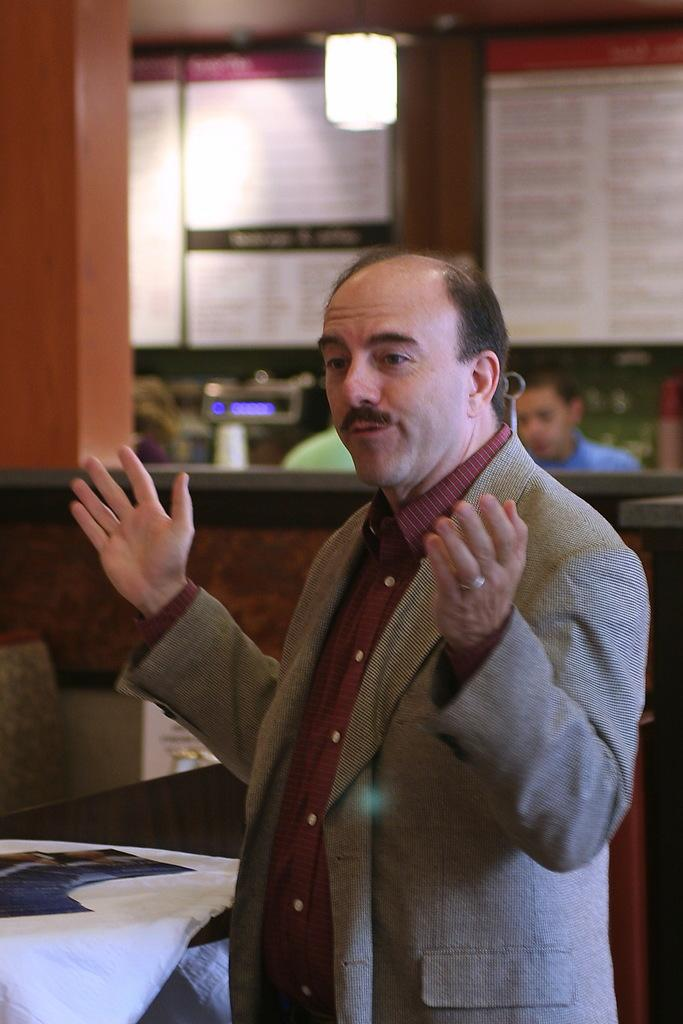What is the person in the image wearing? There is a person wearing a suit in the image. What is the person in the suit doing? The person is standing. What can be seen in the background of the image? There are other people sitting in the background of the image, and there is a wall visible. What type of pickle is the person holding in the image? There is no pickle present in the image. Is the person carrying a bucket in the image? There is no bucket present in the image. 